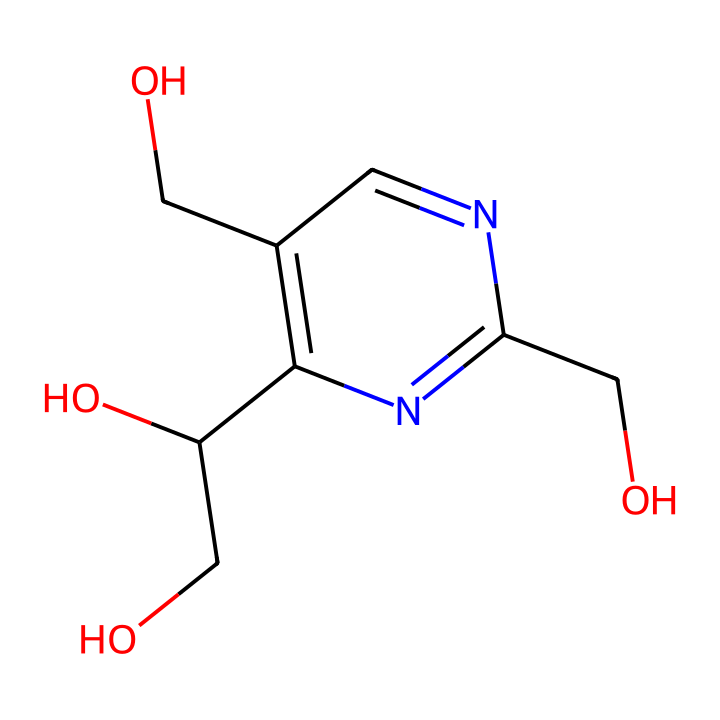What is the name of this vitamin? The chemical structure corresponds to pyridoxine, which is commonly known as Vitamin B6. The nitrogen and alcohol groups in the structure indicate its classification as a vitamin.
Answer: Vitamin B6 How many carbon atoms are present in this vitamin? By examining the structure, we can count the carbon atoms represented in the molecule. There are 8 carbon atoms in the complete structure.
Answer: 8 What functional groups are present in this molecule? Looking at the structure, we can identify hydroxyl (-OH) groups and an amine (-NH) group. The presence of these groups defines its reactivity and solubility.
Answer: hydroxyl and amine How many rings are in this chemical structure? The visual of the molecule reveals a single ring structure (the pyridine ring). The presence of a cyclic component is indicative of the specific properties of Vitamin B6.
Answer: 1 What role does Vitamin B6 play in the body? Knowledge of biochemistry indicates that Vitamin B6 is essential for serotonin production, aiding in mood regulation. This function is critical for maintaining mental health.
Answer: serotonin production What are the implications of a Vitamin B6 deficiency? A deficiency in Vitamin B6 may lead to symptoms such as mood swings and depression due to its role in neurotransmitter production, including serotonin and dopamine.
Answer: mood swings and depression 